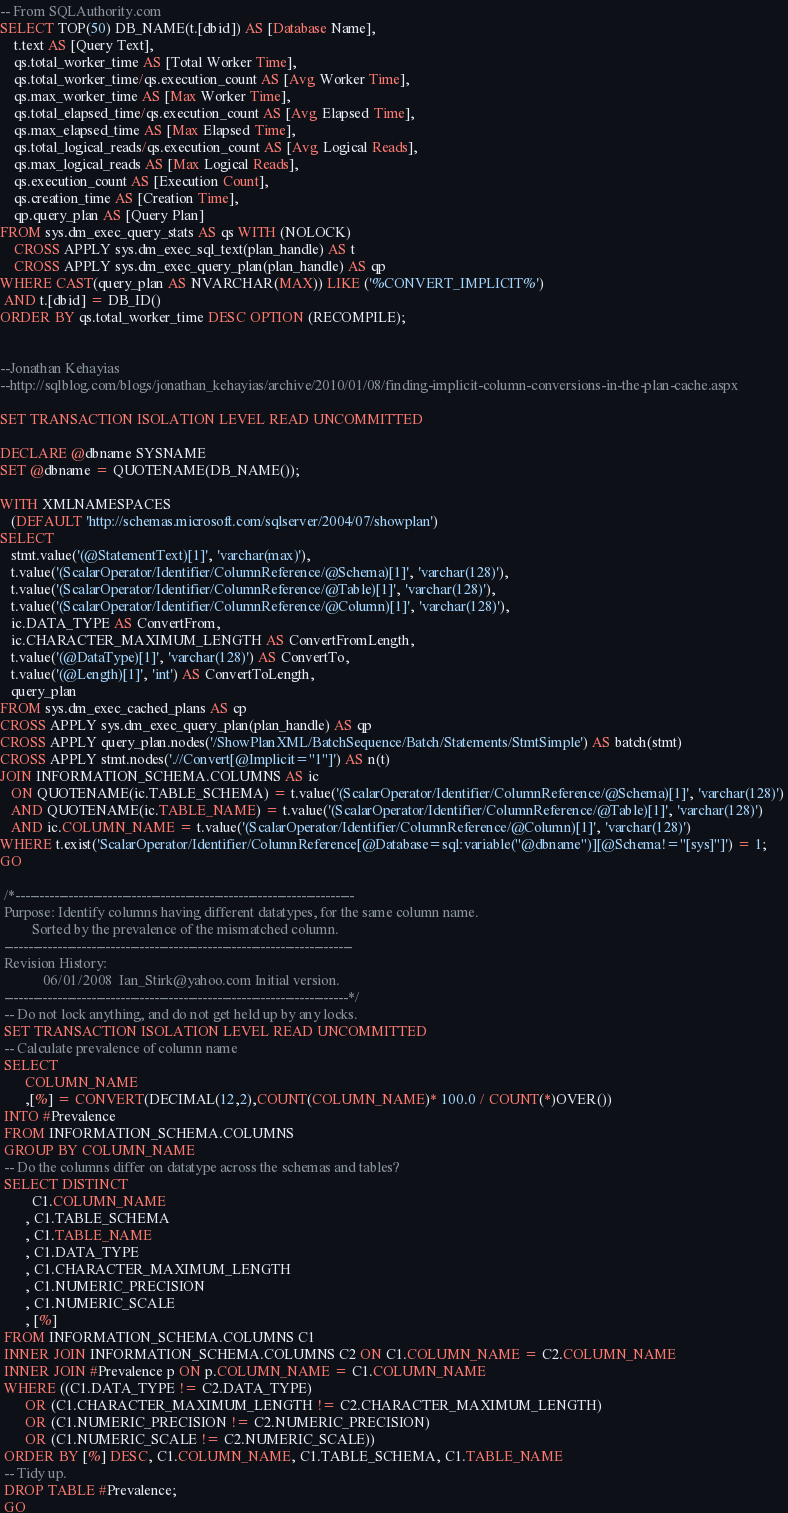<code> <loc_0><loc_0><loc_500><loc_500><_SQL_>-- From SQLAuthority.com
SELECT TOP(50) DB_NAME(t.[dbid]) AS [Database Name], 
	t.text AS [Query Text],
	qs.total_worker_time AS [Total Worker Time], 
	qs.total_worker_time/qs.execution_count AS [Avg Worker Time], 
	qs.max_worker_time AS [Max Worker Time], 
	qs.total_elapsed_time/qs.execution_count AS [Avg Elapsed Time], 
	qs.max_elapsed_time AS [Max Elapsed Time],
	qs.total_logical_reads/qs.execution_count AS [Avg Logical Reads],
	qs.max_logical_reads AS [Max Logical Reads], 
	qs.execution_count AS [Execution Count], 
	qs.creation_time AS [Creation Time],
	qp.query_plan AS [Query Plan]
FROM sys.dm_exec_query_stats AS qs WITH (NOLOCK)
	CROSS APPLY sys.dm_exec_sql_text(plan_handle) AS t 
	CROSS APPLY sys.dm_exec_query_plan(plan_handle) AS qp 
WHERE CAST(query_plan AS NVARCHAR(MAX)) LIKE ('%CONVERT_IMPLICIT%')
 AND t.[dbid] = DB_ID()
ORDER BY qs.total_worker_time DESC OPTION (RECOMPILE);


--Jonathan Kehayias
--http://sqlblog.com/blogs/jonathan_kehayias/archive/2010/01/08/finding-implicit-column-conversions-in-the-plan-cache.aspx

SET TRANSACTION ISOLATION LEVEL READ UNCOMMITTED 

DECLARE @dbname SYSNAME 
SET @dbname = QUOTENAME(DB_NAME()); 

WITH XMLNAMESPACES 
   (DEFAULT 'http://schemas.microsoft.com/sqlserver/2004/07/showplan') 
SELECT 
   stmt.value('(@StatementText)[1]', 'varchar(max)'), 
   t.value('(ScalarOperator/Identifier/ColumnReference/@Schema)[1]', 'varchar(128)'), 
   t.value('(ScalarOperator/Identifier/ColumnReference/@Table)[1]', 'varchar(128)'), 
   t.value('(ScalarOperator/Identifier/ColumnReference/@Column)[1]', 'varchar(128)'), 
   ic.DATA_TYPE AS ConvertFrom, 
   ic.CHARACTER_MAXIMUM_LENGTH AS ConvertFromLength, 
   t.value('(@DataType)[1]', 'varchar(128)') AS ConvertTo, 
   t.value('(@Length)[1]', 'int') AS ConvertToLength, 
   query_plan 
FROM sys.dm_exec_cached_plans AS cp 
CROSS APPLY sys.dm_exec_query_plan(plan_handle) AS qp 
CROSS APPLY query_plan.nodes('/ShowPlanXML/BatchSequence/Batch/Statements/StmtSimple') AS batch(stmt) 
CROSS APPLY stmt.nodes('.//Convert[@Implicit="1"]') AS n(t) 
JOIN INFORMATION_SCHEMA.COLUMNS AS ic 
   ON QUOTENAME(ic.TABLE_SCHEMA) = t.value('(ScalarOperator/Identifier/ColumnReference/@Schema)[1]', 'varchar(128)') 
   AND QUOTENAME(ic.TABLE_NAME) = t.value('(ScalarOperator/Identifier/ColumnReference/@Table)[1]', 'varchar(128)') 
   AND ic.COLUMN_NAME = t.value('(ScalarOperator/Identifier/ColumnReference/@Column)[1]', 'varchar(128)') 
WHERE t.exist('ScalarOperator/Identifier/ColumnReference[@Database=sql:variable("@dbname")][@Schema!="[sys]"]') = 1;
GO

 /*----------------------------------------------------------------------
 Purpose: Identify columns having different datatypes, for the same column name.
		 Sorted by the prevalence of the mismatched column.
 ------------------------------------------------------------------------
 Revision History:
			06/01/2008  Ian_Stirk@yahoo.com Initial version.
 -----------------------------------------------------------------------*/
 -- Do not lock anything, and do not get held up by any locks.
 SET TRANSACTION ISOLATION LEVEL READ UNCOMMITTED
 -- Calculate prevalence of column name
 SELECT
	   COLUMN_NAME
	   ,[%] = CONVERT(DECIMAL(12,2),COUNT(COLUMN_NAME)* 100.0 / COUNT(*)OVER())
 INTO #Prevalence
 FROM INFORMATION_SCHEMA.COLUMNS
 GROUP BY COLUMN_NAME
 -- Do the columns differ on datatype across the schemas and tables?
 SELECT DISTINCT
		 C1.COLUMN_NAME
	   , C1.TABLE_SCHEMA
	   , C1.TABLE_NAME
	   , C1.DATA_TYPE
	   , C1.CHARACTER_MAXIMUM_LENGTH
	   , C1.NUMERIC_PRECISION
	   , C1.NUMERIC_SCALE
	   , [%]
 FROM INFORMATION_SCHEMA.COLUMNS C1
 INNER JOIN INFORMATION_SCHEMA.COLUMNS C2 ON C1.COLUMN_NAME = C2.COLUMN_NAME
 INNER JOIN #Prevalence p ON p.COLUMN_NAME = C1.COLUMN_NAME
 WHERE ((C1.DATA_TYPE != C2.DATA_TYPE)
	   OR (C1.CHARACTER_MAXIMUM_LENGTH != C2.CHARACTER_MAXIMUM_LENGTH)
	   OR (C1.NUMERIC_PRECISION != C2.NUMERIC_PRECISION)
	   OR (C1.NUMERIC_SCALE != C2.NUMERIC_SCALE))
 ORDER BY [%] DESC, C1.COLUMN_NAME, C1.TABLE_SCHEMA, C1.TABLE_NAME
 -- Tidy up.
 DROP TABLE #Prevalence;
 GO</code> 